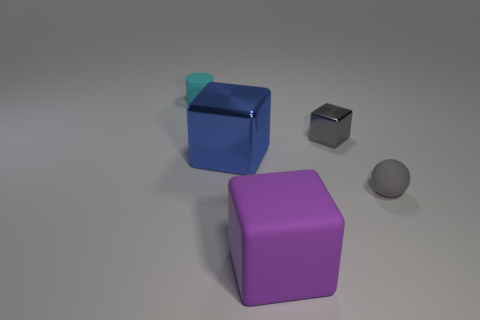Do the cyan cylinder and the gray ball have the same material?
Make the answer very short. Yes. What color is the tiny rubber object to the right of the small rubber object behind the big blue shiny object?
Give a very brief answer. Gray. There is a purple object that is made of the same material as the gray ball; what size is it?
Offer a very short reply. Large. How many shiny things are the same shape as the cyan rubber thing?
Keep it short and to the point. 0. How many things are either tiny matte objects behind the small gray metallic object or small objects that are on the right side of the tiny cylinder?
Offer a terse response. 3. There is a gray object on the left side of the gray matte thing; what number of tiny matte things are left of it?
Provide a succinct answer. 1. There is a rubber thing behind the gray rubber sphere; does it have the same shape as the tiny rubber object in front of the large blue cube?
Offer a very short reply. No. What is the shape of the object that is the same color as the ball?
Give a very brief answer. Cube. Are there any tiny red cylinders that have the same material as the purple block?
Your answer should be very brief. No. What number of metallic objects are cylinders or large blue cylinders?
Offer a very short reply. 0. 